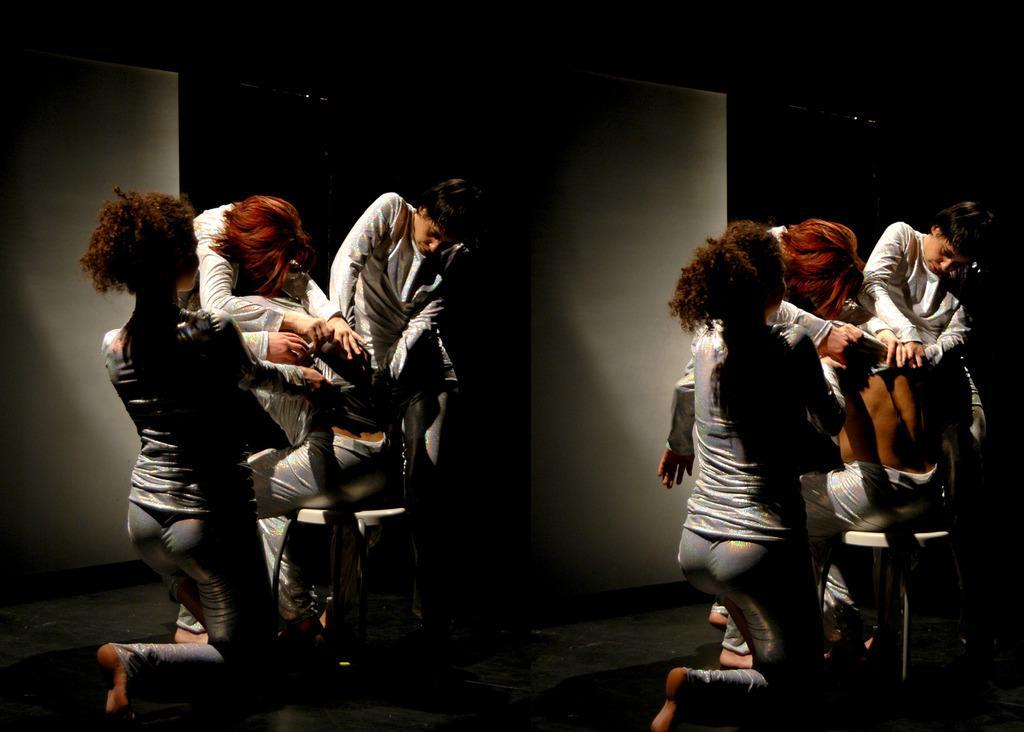How would you summarize this image in a sentence or two? In this image we can see few people in a room a person sitting on the stool and a wall in the background. 